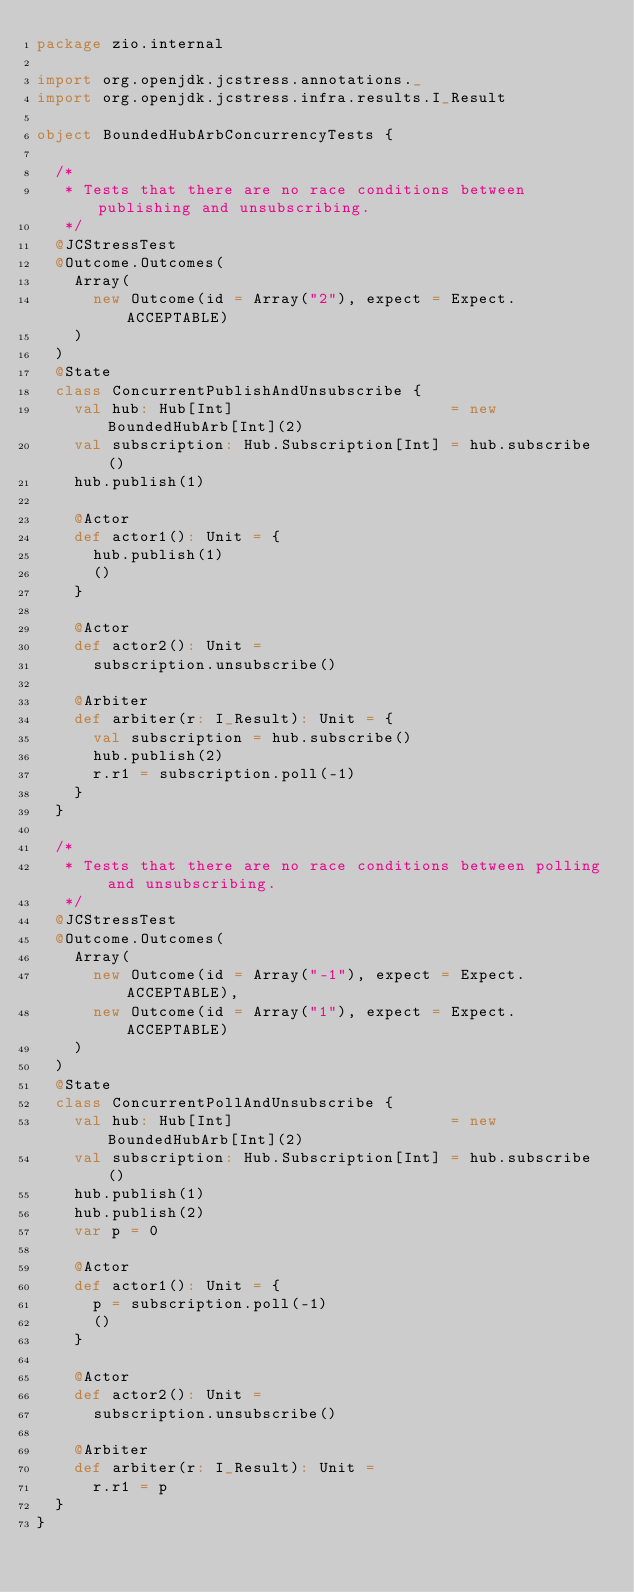Convert code to text. <code><loc_0><loc_0><loc_500><loc_500><_Scala_>package zio.internal

import org.openjdk.jcstress.annotations._
import org.openjdk.jcstress.infra.results.I_Result

object BoundedHubArbConcurrencyTests {

  /*
   * Tests that there are no race conditions between publishing and unsubscribing.
   */
  @JCStressTest
  @Outcome.Outcomes(
    Array(
      new Outcome(id = Array("2"), expect = Expect.ACCEPTABLE)
    )
  )
  @State
  class ConcurrentPublishAndUnsubscribe {
    val hub: Hub[Int]                       = new BoundedHubArb[Int](2)
    val subscription: Hub.Subscription[Int] = hub.subscribe()
    hub.publish(1)

    @Actor
    def actor1(): Unit = {
      hub.publish(1)
      ()
    }

    @Actor
    def actor2(): Unit =
      subscription.unsubscribe()

    @Arbiter
    def arbiter(r: I_Result): Unit = {
      val subscription = hub.subscribe()
      hub.publish(2)
      r.r1 = subscription.poll(-1)
    }
  }

  /*
   * Tests that there are no race conditions between polling and unsubscribing.
   */
  @JCStressTest
  @Outcome.Outcomes(
    Array(
      new Outcome(id = Array("-1"), expect = Expect.ACCEPTABLE),
      new Outcome(id = Array("1"), expect = Expect.ACCEPTABLE)
    )
  )
  @State
  class ConcurrentPollAndUnsubscribe {
    val hub: Hub[Int]                       = new BoundedHubArb[Int](2)
    val subscription: Hub.Subscription[Int] = hub.subscribe()
    hub.publish(1)
    hub.publish(2)
    var p = 0

    @Actor
    def actor1(): Unit = {
      p = subscription.poll(-1)
      ()
    }

    @Actor
    def actor2(): Unit =
      subscription.unsubscribe()

    @Arbiter
    def arbiter(r: I_Result): Unit =
      r.r1 = p
  }
}
</code> 